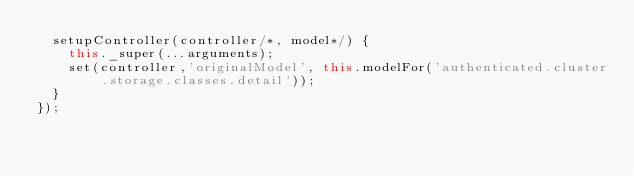<code> <loc_0><loc_0><loc_500><loc_500><_JavaScript_>  setupController(controller/*, model*/) {
    this._super(...arguments);
    set(controller,'originalModel', this.modelFor('authenticated.cluster.storage.classes.detail'));
  }
});
</code> 